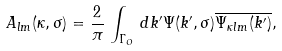<formula> <loc_0><loc_0><loc_500><loc_500>A _ { l m } ( \kappa , \sigma ) = \frac { 2 } { \pi } \, \int _ { \Gamma _ { O } } \, d k ^ { \prime } \Psi ( k ^ { \prime } , \sigma ) \overline { \Psi _ { \kappa l m } ( k ^ { \prime } ) } ,</formula> 